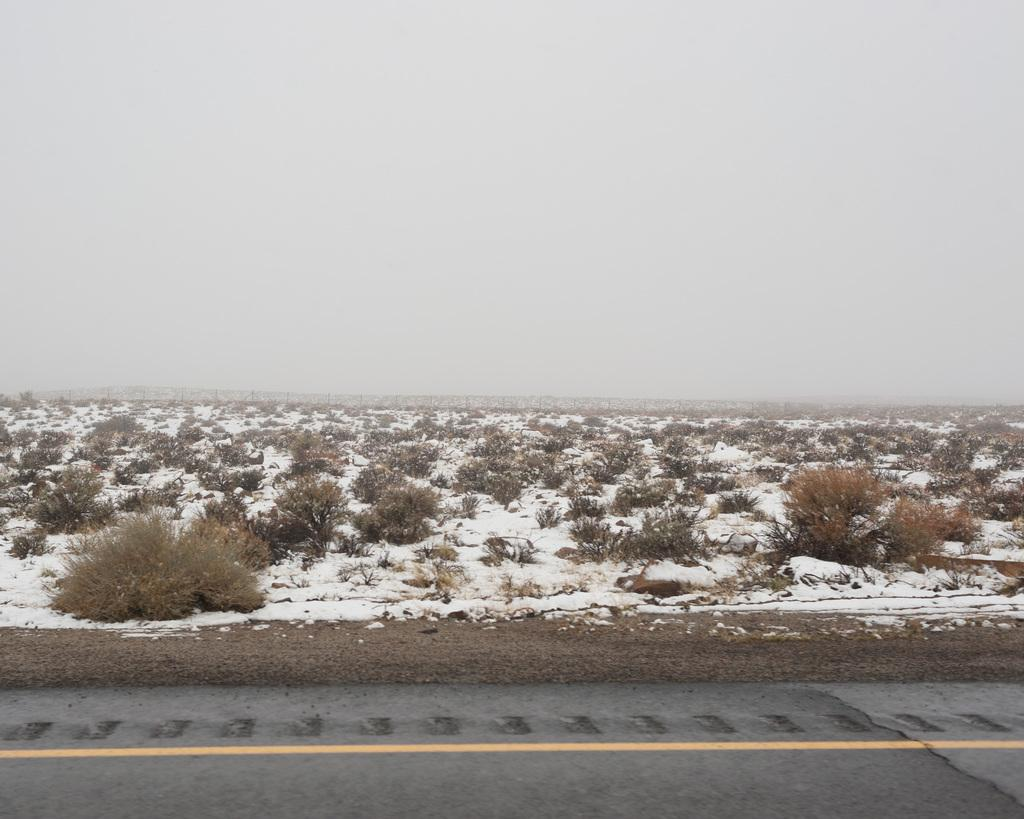What celestial bodies can be seen in the image? There are planets visible in the image. What is present on the ground in the image? There is ice on the ground in the image. What part of the natural environment is visible in the image? The sky is visible at the top of the image. When was the image taken? The image was taken during the day. What grade did the baby receive for their performance in the image? There is no baby present in the image, and therefore no performance or grade can be assessed. 